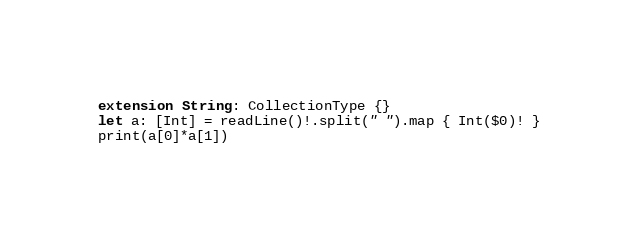<code> <loc_0><loc_0><loc_500><loc_500><_Swift_>extension String: CollectionType {}
let a: [Int] = readLine()!.split(" ").map { Int($0)! }
print(a[0]*a[1])</code> 